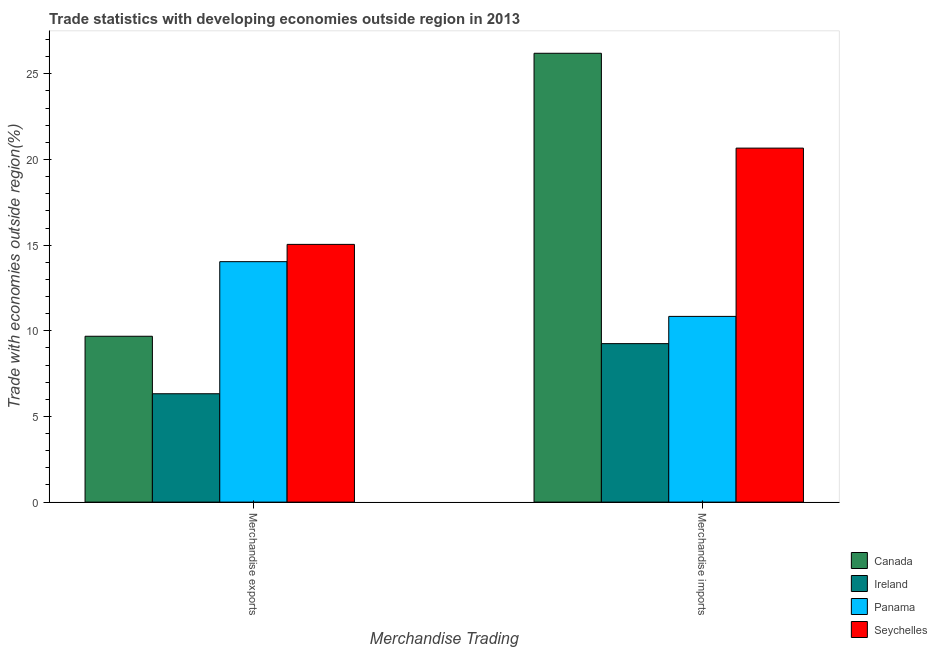How many different coloured bars are there?
Your answer should be compact. 4. Are the number of bars per tick equal to the number of legend labels?
Your response must be concise. Yes. Are the number of bars on each tick of the X-axis equal?
Your answer should be compact. Yes. How many bars are there on the 2nd tick from the left?
Offer a very short reply. 4. How many bars are there on the 1st tick from the right?
Give a very brief answer. 4. What is the label of the 2nd group of bars from the left?
Keep it short and to the point. Merchandise imports. What is the merchandise exports in Seychelles?
Your response must be concise. 15.05. Across all countries, what is the maximum merchandise imports?
Give a very brief answer. 26.2. Across all countries, what is the minimum merchandise imports?
Provide a short and direct response. 9.25. In which country was the merchandise imports maximum?
Provide a short and direct response. Canada. In which country was the merchandise exports minimum?
Provide a succinct answer. Ireland. What is the total merchandise imports in the graph?
Ensure brevity in your answer.  66.96. What is the difference between the merchandise exports in Canada and that in Seychelles?
Give a very brief answer. -5.36. What is the difference between the merchandise imports in Canada and the merchandise exports in Seychelles?
Your answer should be very brief. 11.16. What is the average merchandise imports per country?
Provide a short and direct response. 16.74. What is the difference between the merchandise imports and merchandise exports in Panama?
Your answer should be very brief. -3.2. In how many countries, is the merchandise exports greater than 1 %?
Your answer should be very brief. 4. What is the ratio of the merchandise imports in Canada to that in Panama?
Offer a terse response. 2.42. Is the merchandise exports in Panama less than that in Canada?
Make the answer very short. No. In how many countries, is the merchandise imports greater than the average merchandise imports taken over all countries?
Provide a succinct answer. 2. What does the 3rd bar from the left in Merchandise exports represents?
Provide a succinct answer. Panama. How many bars are there?
Your response must be concise. 8. Are all the bars in the graph horizontal?
Provide a short and direct response. No. How many countries are there in the graph?
Your response must be concise. 4. What is the difference between two consecutive major ticks on the Y-axis?
Give a very brief answer. 5. Are the values on the major ticks of Y-axis written in scientific E-notation?
Give a very brief answer. No. Does the graph contain any zero values?
Keep it short and to the point. No. Where does the legend appear in the graph?
Your answer should be very brief. Bottom right. How many legend labels are there?
Provide a succinct answer. 4. What is the title of the graph?
Your answer should be compact. Trade statistics with developing economies outside region in 2013. Does "Guinea-Bissau" appear as one of the legend labels in the graph?
Make the answer very short. No. What is the label or title of the X-axis?
Provide a short and direct response. Merchandise Trading. What is the label or title of the Y-axis?
Give a very brief answer. Trade with economies outside region(%). What is the Trade with economies outside region(%) in Canada in Merchandise exports?
Your response must be concise. 9.68. What is the Trade with economies outside region(%) in Ireland in Merchandise exports?
Provide a succinct answer. 6.33. What is the Trade with economies outside region(%) of Panama in Merchandise exports?
Give a very brief answer. 14.04. What is the Trade with economies outside region(%) in Seychelles in Merchandise exports?
Keep it short and to the point. 15.05. What is the Trade with economies outside region(%) in Canada in Merchandise imports?
Offer a terse response. 26.2. What is the Trade with economies outside region(%) in Ireland in Merchandise imports?
Ensure brevity in your answer.  9.25. What is the Trade with economies outside region(%) of Panama in Merchandise imports?
Give a very brief answer. 10.84. What is the Trade with economies outside region(%) of Seychelles in Merchandise imports?
Your answer should be very brief. 20.66. Across all Merchandise Trading, what is the maximum Trade with economies outside region(%) in Canada?
Provide a succinct answer. 26.2. Across all Merchandise Trading, what is the maximum Trade with economies outside region(%) in Ireland?
Offer a terse response. 9.25. Across all Merchandise Trading, what is the maximum Trade with economies outside region(%) in Panama?
Give a very brief answer. 14.04. Across all Merchandise Trading, what is the maximum Trade with economies outside region(%) in Seychelles?
Provide a short and direct response. 20.66. Across all Merchandise Trading, what is the minimum Trade with economies outside region(%) in Canada?
Your answer should be compact. 9.68. Across all Merchandise Trading, what is the minimum Trade with economies outside region(%) in Ireland?
Give a very brief answer. 6.33. Across all Merchandise Trading, what is the minimum Trade with economies outside region(%) of Panama?
Your answer should be very brief. 10.84. Across all Merchandise Trading, what is the minimum Trade with economies outside region(%) in Seychelles?
Keep it short and to the point. 15.05. What is the total Trade with economies outside region(%) in Canada in the graph?
Your answer should be very brief. 35.88. What is the total Trade with economies outside region(%) of Ireland in the graph?
Give a very brief answer. 15.58. What is the total Trade with economies outside region(%) in Panama in the graph?
Keep it short and to the point. 24.88. What is the total Trade with economies outside region(%) in Seychelles in the graph?
Provide a succinct answer. 35.71. What is the difference between the Trade with economies outside region(%) of Canada in Merchandise exports and that in Merchandise imports?
Keep it short and to the point. -16.52. What is the difference between the Trade with economies outside region(%) of Ireland in Merchandise exports and that in Merchandise imports?
Make the answer very short. -2.93. What is the difference between the Trade with economies outside region(%) of Panama in Merchandise exports and that in Merchandise imports?
Keep it short and to the point. 3.2. What is the difference between the Trade with economies outside region(%) of Seychelles in Merchandise exports and that in Merchandise imports?
Your answer should be compact. -5.62. What is the difference between the Trade with economies outside region(%) of Canada in Merchandise exports and the Trade with economies outside region(%) of Ireland in Merchandise imports?
Your response must be concise. 0.43. What is the difference between the Trade with economies outside region(%) in Canada in Merchandise exports and the Trade with economies outside region(%) in Panama in Merchandise imports?
Give a very brief answer. -1.16. What is the difference between the Trade with economies outside region(%) in Canada in Merchandise exports and the Trade with economies outside region(%) in Seychelles in Merchandise imports?
Your answer should be very brief. -10.98. What is the difference between the Trade with economies outside region(%) in Ireland in Merchandise exports and the Trade with economies outside region(%) in Panama in Merchandise imports?
Ensure brevity in your answer.  -4.52. What is the difference between the Trade with economies outside region(%) in Ireland in Merchandise exports and the Trade with economies outside region(%) in Seychelles in Merchandise imports?
Your answer should be very brief. -14.34. What is the difference between the Trade with economies outside region(%) in Panama in Merchandise exports and the Trade with economies outside region(%) in Seychelles in Merchandise imports?
Your answer should be compact. -6.63. What is the average Trade with economies outside region(%) of Canada per Merchandise Trading?
Your response must be concise. 17.94. What is the average Trade with economies outside region(%) of Ireland per Merchandise Trading?
Keep it short and to the point. 7.79. What is the average Trade with economies outside region(%) of Panama per Merchandise Trading?
Provide a short and direct response. 12.44. What is the average Trade with economies outside region(%) of Seychelles per Merchandise Trading?
Make the answer very short. 17.85. What is the difference between the Trade with economies outside region(%) in Canada and Trade with economies outside region(%) in Ireland in Merchandise exports?
Make the answer very short. 3.36. What is the difference between the Trade with economies outside region(%) in Canada and Trade with economies outside region(%) in Panama in Merchandise exports?
Provide a succinct answer. -4.35. What is the difference between the Trade with economies outside region(%) in Canada and Trade with economies outside region(%) in Seychelles in Merchandise exports?
Ensure brevity in your answer.  -5.36. What is the difference between the Trade with economies outside region(%) in Ireland and Trade with economies outside region(%) in Panama in Merchandise exports?
Offer a terse response. -7.71. What is the difference between the Trade with economies outside region(%) in Ireland and Trade with economies outside region(%) in Seychelles in Merchandise exports?
Give a very brief answer. -8.72. What is the difference between the Trade with economies outside region(%) in Panama and Trade with economies outside region(%) in Seychelles in Merchandise exports?
Ensure brevity in your answer.  -1.01. What is the difference between the Trade with economies outside region(%) in Canada and Trade with economies outside region(%) in Ireland in Merchandise imports?
Make the answer very short. 16.95. What is the difference between the Trade with economies outside region(%) of Canada and Trade with economies outside region(%) of Panama in Merchandise imports?
Ensure brevity in your answer.  15.36. What is the difference between the Trade with economies outside region(%) of Canada and Trade with economies outside region(%) of Seychelles in Merchandise imports?
Your answer should be very brief. 5.54. What is the difference between the Trade with economies outside region(%) of Ireland and Trade with economies outside region(%) of Panama in Merchandise imports?
Offer a terse response. -1.59. What is the difference between the Trade with economies outside region(%) in Ireland and Trade with economies outside region(%) in Seychelles in Merchandise imports?
Provide a short and direct response. -11.41. What is the difference between the Trade with economies outside region(%) of Panama and Trade with economies outside region(%) of Seychelles in Merchandise imports?
Ensure brevity in your answer.  -9.82. What is the ratio of the Trade with economies outside region(%) of Canada in Merchandise exports to that in Merchandise imports?
Your answer should be very brief. 0.37. What is the ratio of the Trade with economies outside region(%) of Ireland in Merchandise exports to that in Merchandise imports?
Give a very brief answer. 0.68. What is the ratio of the Trade with economies outside region(%) in Panama in Merchandise exports to that in Merchandise imports?
Your answer should be compact. 1.29. What is the ratio of the Trade with economies outside region(%) in Seychelles in Merchandise exports to that in Merchandise imports?
Offer a terse response. 0.73. What is the difference between the highest and the second highest Trade with economies outside region(%) in Canada?
Ensure brevity in your answer.  16.52. What is the difference between the highest and the second highest Trade with economies outside region(%) in Ireland?
Your answer should be compact. 2.93. What is the difference between the highest and the second highest Trade with economies outside region(%) in Panama?
Offer a terse response. 3.2. What is the difference between the highest and the second highest Trade with economies outside region(%) of Seychelles?
Ensure brevity in your answer.  5.62. What is the difference between the highest and the lowest Trade with economies outside region(%) of Canada?
Offer a very short reply. 16.52. What is the difference between the highest and the lowest Trade with economies outside region(%) in Ireland?
Provide a short and direct response. 2.93. What is the difference between the highest and the lowest Trade with economies outside region(%) in Panama?
Keep it short and to the point. 3.2. What is the difference between the highest and the lowest Trade with economies outside region(%) in Seychelles?
Your answer should be compact. 5.62. 